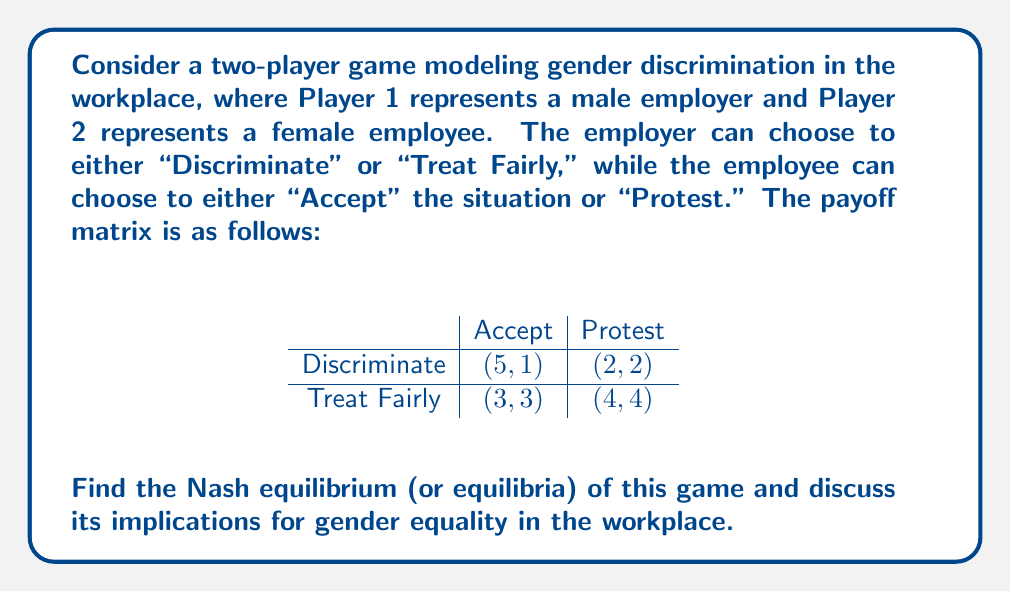Can you solve this math problem? To find the Nash equilibrium, we need to analyze each player's best response to the other player's strategy:

1. For the employer (Player 1):
   - If the employee accepts, the employer's best choice is to discriminate (5 > 3).
   - If the employee protests, the employer's best choice is to treat fairly (4 > 2).

2. For the employee (Player 2):
   - If the employer discriminates, the employee's best choice is to protest (2 > 1).
   - If the employer treats fairly, the employee's best choice is to protest (4 > 3).

From this analysis, we can see that there is one pure strategy Nash equilibrium: (Treat Fairly, Protest) with payoffs (4, 4).

To check if there are any mixed strategy equilibria, we need to calculate the indifference probabilities:

Let $p$ be the probability that the employer discriminates, and $q$ be the probability that the employee accepts.

For the employee to be indifferent:
$$ 1q + 2(1-q) = 3q + 4(1-q) $$
$$ q = 2/3 $$

For the employer to be indifferent:
$$ 5p + 3(1-p) = 2p + 4(1-p) $$
$$ p = 1/3 $$

However, these probabilities don't constitute a Nash equilibrium because the best response to the opponent's mixed strategy is always a pure strategy in this case.

Therefore, the only Nash equilibrium is (Treat Fairly, Protest) with payoffs (4, 4).

This equilibrium suggests that in a workplace where employees are empowered to protest against discrimination, the optimal strategy for employers is to treat all employees fairly, regardless of gender. This outcome aligns with the goals of gender equality and demonstrates how collective action (protesting) can lead to fair treatment in the workplace.
Answer: The Nash equilibrium is (Treat Fairly, Protest) with payoffs (4, 4). 